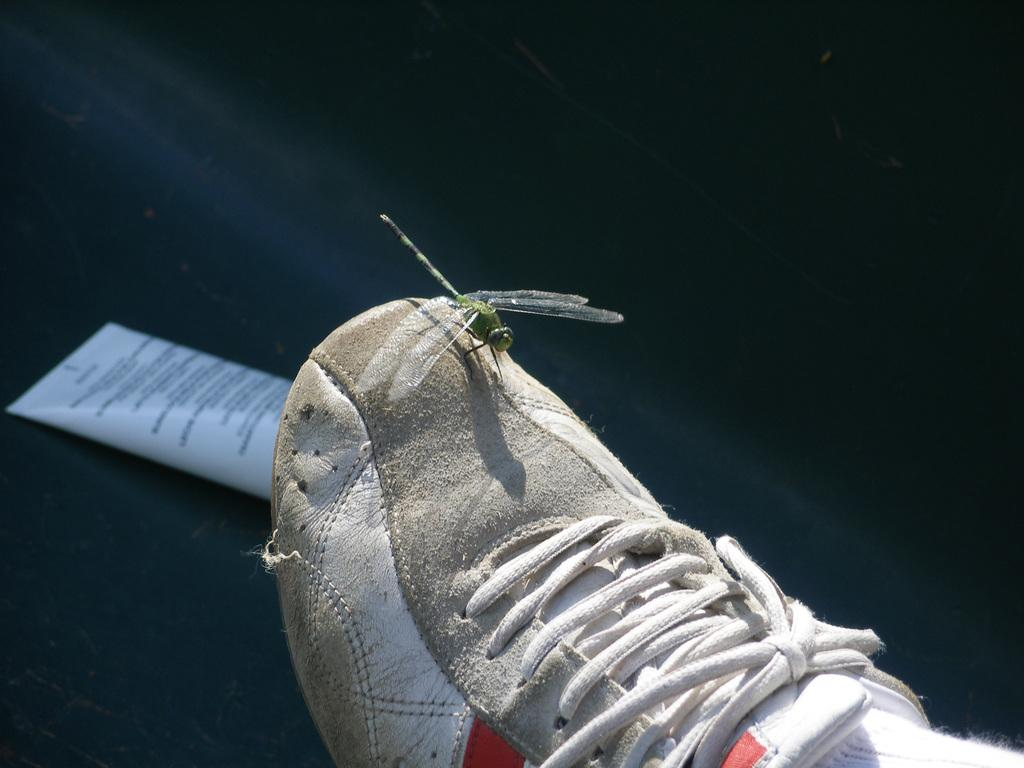What is the fly doing in the image? The fly is sitting on a person's shoe in the image. Can you describe any other objects or items on the floor? There may be a packet on the floor, but it is not clearly visible. Based on the lighting in the image, when do you think it was taken? The image was likely taken during the day, as there is sufficient natural light. How many trees can be seen in the image? There are no trees visible in the image. What color are the person's eyes in the image? The person's eyes are not visible in the image, as only their shoe and the fly are shown. 